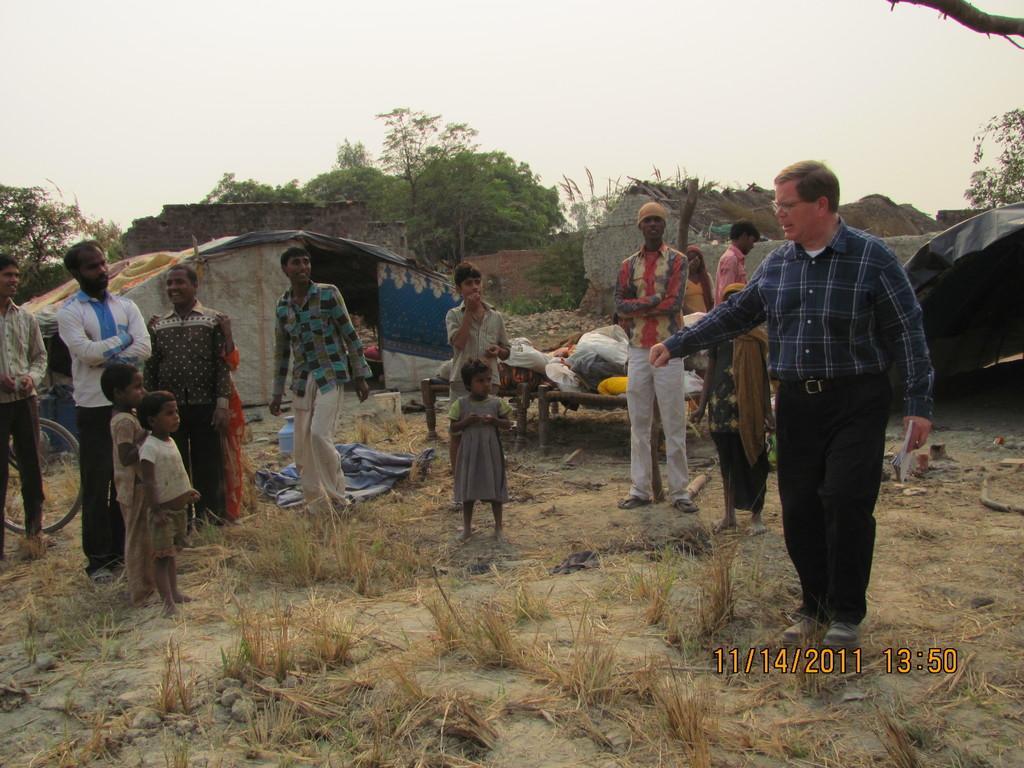Could you give a brief overview of what you see in this image? As we can see in the image there is dry grass, few people here and there, houses, trees and on the top there is sky. 